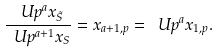Convert formula to latex. <formula><loc_0><loc_0><loc_500><loc_500>\frac { \ U p ^ { a } x _ { \tilde { S } } } { \ U p ^ { a + 1 } x _ { S } } = x _ { a + 1 , p } = \ U p ^ { a } x _ { 1 , p } .</formula> 